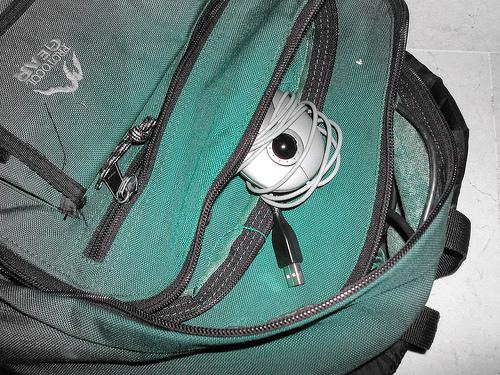Question: what color is the backpack?
Choices:
A. Red.
B. Blue.
C. Aqua.
D. Green.
Answer with the letter. Answer: D Question: what color is the floor?
Choices:
A. Brown.
B. Black.
C. Tan.
D. Gray.
Answer with the letter. Answer: D 